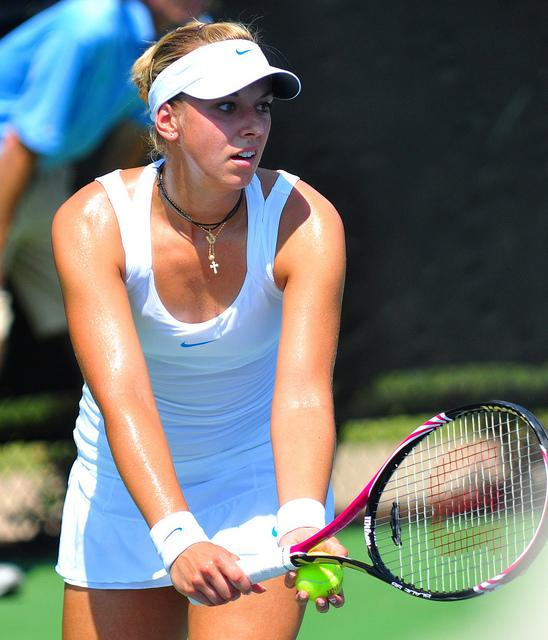When an athlete starts to overheat and sweat starts pouring there body is asking for what to replenish it? water 